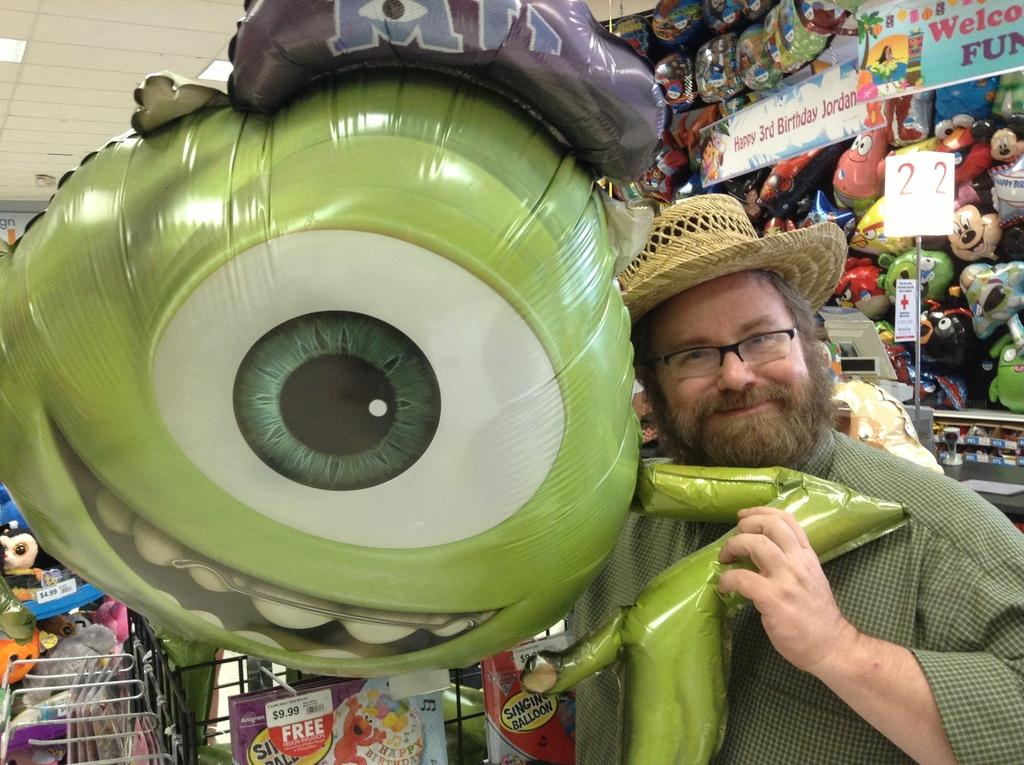What can be seen on the racks in the image? There are toys on the racks in the image. What is written on the boards in the image? There are boards with text in the image. What is the person holding in the image? A person is holding a balloon in the image. What can be seen illuminating the area in the image? There are lights visible in the image. What type of ticket is the person holding in the image? There is no ticket present in the image; the person is holding a balloon. What is the reaction of the toys to the person holding the balloon? The toys do not have a reaction, as they are inanimate objects. 